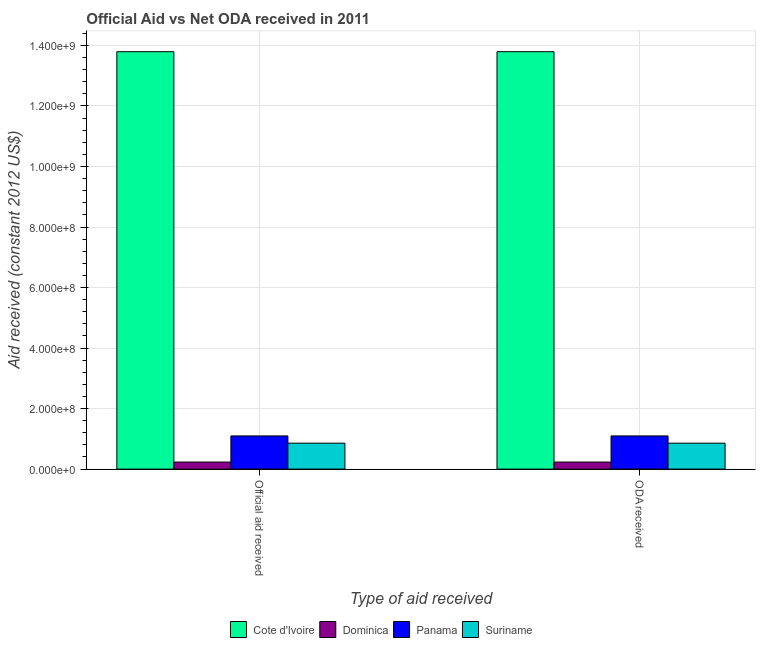How many different coloured bars are there?
Give a very brief answer. 4. How many bars are there on the 1st tick from the left?
Provide a short and direct response. 4. What is the label of the 2nd group of bars from the left?
Ensure brevity in your answer.  ODA received. What is the oda received in Suriname?
Keep it short and to the point. 8.57e+07. Across all countries, what is the maximum official aid received?
Provide a short and direct response. 1.38e+09. Across all countries, what is the minimum oda received?
Offer a terse response. 2.33e+07. In which country was the oda received maximum?
Offer a terse response. Cote d'Ivoire. In which country was the official aid received minimum?
Keep it short and to the point. Dominica. What is the total oda received in the graph?
Offer a terse response. 1.60e+09. What is the difference between the oda received in Panama and that in Dominica?
Keep it short and to the point. 8.63e+07. What is the difference between the official aid received in Cote d'Ivoire and the oda received in Suriname?
Make the answer very short. 1.29e+09. What is the average oda received per country?
Give a very brief answer. 4.00e+08. What is the ratio of the oda received in Dominica to that in Panama?
Your answer should be very brief. 0.21. In how many countries, is the oda received greater than the average oda received taken over all countries?
Your response must be concise. 1. What does the 3rd bar from the left in Official aid received represents?
Your response must be concise. Panama. What does the 4th bar from the right in ODA received represents?
Ensure brevity in your answer.  Cote d'Ivoire. Are all the bars in the graph horizontal?
Your answer should be very brief. No. What is the difference between two consecutive major ticks on the Y-axis?
Give a very brief answer. 2.00e+08. How are the legend labels stacked?
Ensure brevity in your answer.  Horizontal. What is the title of the graph?
Make the answer very short. Official Aid vs Net ODA received in 2011 . What is the label or title of the X-axis?
Give a very brief answer. Type of aid received. What is the label or title of the Y-axis?
Ensure brevity in your answer.  Aid received (constant 2012 US$). What is the Aid received (constant 2012 US$) in Cote d'Ivoire in Official aid received?
Make the answer very short. 1.38e+09. What is the Aid received (constant 2012 US$) in Dominica in Official aid received?
Provide a short and direct response. 2.33e+07. What is the Aid received (constant 2012 US$) of Panama in Official aid received?
Offer a terse response. 1.10e+08. What is the Aid received (constant 2012 US$) in Suriname in Official aid received?
Offer a terse response. 8.57e+07. What is the Aid received (constant 2012 US$) of Cote d'Ivoire in ODA received?
Ensure brevity in your answer.  1.38e+09. What is the Aid received (constant 2012 US$) of Dominica in ODA received?
Provide a short and direct response. 2.33e+07. What is the Aid received (constant 2012 US$) of Panama in ODA received?
Ensure brevity in your answer.  1.10e+08. What is the Aid received (constant 2012 US$) in Suriname in ODA received?
Ensure brevity in your answer.  8.57e+07. Across all Type of aid received, what is the maximum Aid received (constant 2012 US$) of Cote d'Ivoire?
Give a very brief answer. 1.38e+09. Across all Type of aid received, what is the maximum Aid received (constant 2012 US$) of Dominica?
Your response must be concise. 2.33e+07. Across all Type of aid received, what is the maximum Aid received (constant 2012 US$) in Panama?
Your answer should be compact. 1.10e+08. Across all Type of aid received, what is the maximum Aid received (constant 2012 US$) of Suriname?
Your answer should be very brief. 8.57e+07. Across all Type of aid received, what is the minimum Aid received (constant 2012 US$) of Cote d'Ivoire?
Your answer should be compact. 1.38e+09. Across all Type of aid received, what is the minimum Aid received (constant 2012 US$) in Dominica?
Your answer should be very brief. 2.33e+07. Across all Type of aid received, what is the minimum Aid received (constant 2012 US$) of Panama?
Your response must be concise. 1.10e+08. Across all Type of aid received, what is the minimum Aid received (constant 2012 US$) in Suriname?
Your answer should be very brief. 8.57e+07. What is the total Aid received (constant 2012 US$) of Cote d'Ivoire in the graph?
Offer a very short reply. 2.76e+09. What is the total Aid received (constant 2012 US$) of Dominica in the graph?
Provide a short and direct response. 4.66e+07. What is the total Aid received (constant 2012 US$) of Panama in the graph?
Your answer should be compact. 2.19e+08. What is the total Aid received (constant 2012 US$) of Suriname in the graph?
Offer a terse response. 1.71e+08. What is the difference between the Aid received (constant 2012 US$) in Panama in Official aid received and that in ODA received?
Your response must be concise. 0. What is the difference between the Aid received (constant 2012 US$) in Suriname in Official aid received and that in ODA received?
Provide a short and direct response. 0. What is the difference between the Aid received (constant 2012 US$) in Cote d'Ivoire in Official aid received and the Aid received (constant 2012 US$) in Dominica in ODA received?
Ensure brevity in your answer.  1.36e+09. What is the difference between the Aid received (constant 2012 US$) of Cote d'Ivoire in Official aid received and the Aid received (constant 2012 US$) of Panama in ODA received?
Keep it short and to the point. 1.27e+09. What is the difference between the Aid received (constant 2012 US$) in Cote d'Ivoire in Official aid received and the Aid received (constant 2012 US$) in Suriname in ODA received?
Ensure brevity in your answer.  1.29e+09. What is the difference between the Aid received (constant 2012 US$) of Dominica in Official aid received and the Aid received (constant 2012 US$) of Panama in ODA received?
Provide a succinct answer. -8.63e+07. What is the difference between the Aid received (constant 2012 US$) of Dominica in Official aid received and the Aid received (constant 2012 US$) of Suriname in ODA received?
Your answer should be compact. -6.24e+07. What is the difference between the Aid received (constant 2012 US$) of Panama in Official aid received and the Aid received (constant 2012 US$) of Suriname in ODA received?
Your answer should be compact. 2.39e+07. What is the average Aid received (constant 2012 US$) of Cote d'Ivoire per Type of aid received?
Ensure brevity in your answer.  1.38e+09. What is the average Aid received (constant 2012 US$) in Dominica per Type of aid received?
Ensure brevity in your answer.  2.33e+07. What is the average Aid received (constant 2012 US$) in Panama per Type of aid received?
Offer a very short reply. 1.10e+08. What is the average Aid received (constant 2012 US$) in Suriname per Type of aid received?
Make the answer very short. 8.57e+07. What is the difference between the Aid received (constant 2012 US$) in Cote d'Ivoire and Aid received (constant 2012 US$) in Dominica in Official aid received?
Give a very brief answer. 1.36e+09. What is the difference between the Aid received (constant 2012 US$) of Cote d'Ivoire and Aid received (constant 2012 US$) of Panama in Official aid received?
Ensure brevity in your answer.  1.27e+09. What is the difference between the Aid received (constant 2012 US$) of Cote d'Ivoire and Aid received (constant 2012 US$) of Suriname in Official aid received?
Offer a terse response. 1.29e+09. What is the difference between the Aid received (constant 2012 US$) in Dominica and Aid received (constant 2012 US$) in Panama in Official aid received?
Your response must be concise. -8.63e+07. What is the difference between the Aid received (constant 2012 US$) in Dominica and Aid received (constant 2012 US$) in Suriname in Official aid received?
Your response must be concise. -6.24e+07. What is the difference between the Aid received (constant 2012 US$) in Panama and Aid received (constant 2012 US$) in Suriname in Official aid received?
Keep it short and to the point. 2.39e+07. What is the difference between the Aid received (constant 2012 US$) of Cote d'Ivoire and Aid received (constant 2012 US$) of Dominica in ODA received?
Make the answer very short. 1.36e+09. What is the difference between the Aid received (constant 2012 US$) of Cote d'Ivoire and Aid received (constant 2012 US$) of Panama in ODA received?
Your answer should be very brief. 1.27e+09. What is the difference between the Aid received (constant 2012 US$) of Cote d'Ivoire and Aid received (constant 2012 US$) of Suriname in ODA received?
Your answer should be compact. 1.29e+09. What is the difference between the Aid received (constant 2012 US$) in Dominica and Aid received (constant 2012 US$) in Panama in ODA received?
Offer a terse response. -8.63e+07. What is the difference between the Aid received (constant 2012 US$) of Dominica and Aid received (constant 2012 US$) of Suriname in ODA received?
Provide a succinct answer. -6.24e+07. What is the difference between the Aid received (constant 2012 US$) in Panama and Aid received (constant 2012 US$) in Suriname in ODA received?
Make the answer very short. 2.39e+07. What is the ratio of the Aid received (constant 2012 US$) in Cote d'Ivoire in Official aid received to that in ODA received?
Provide a succinct answer. 1. What is the ratio of the Aid received (constant 2012 US$) in Panama in Official aid received to that in ODA received?
Give a very brief answer. 1. What is the difference between the highest and the second highest Aid received (constant 2012 US$) in Cote d'Ivoire?
Your answer should be very brief. 0. What is the difference between the highest and the second highest Aid received (constant 2012 US$) in Dominica?
Provide a succinct answer. 0. What is the difference between the highest and the second highest Aid received (constant 2012 US$) of Panama?
Offer a terse response. 0. What is the difference between the highest and the second highest Aid received (constant 2012 US$) of Suriname?
Keep it short and to the point. 0. 